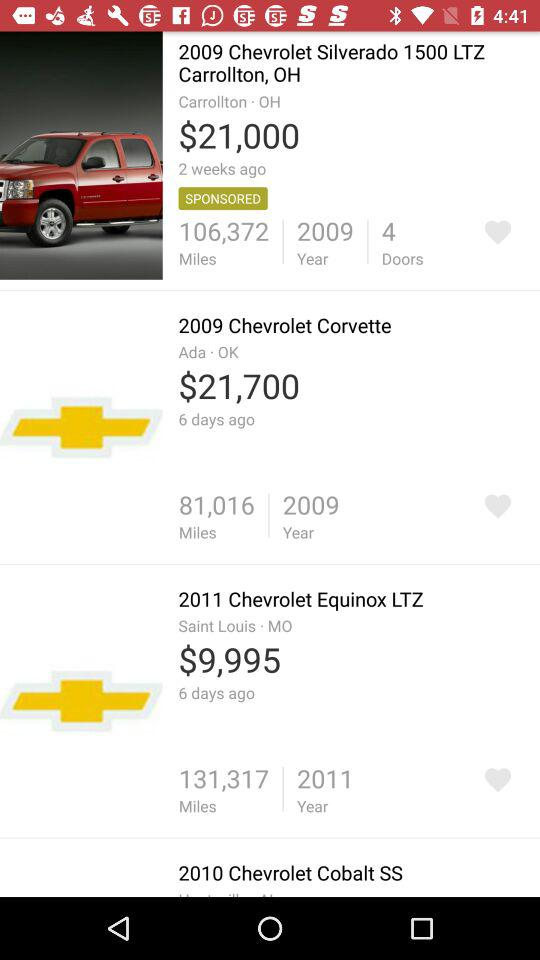What is the seating capacity of a car?
When the provided information is insufficient, respond with <no answer>. <no answer> 